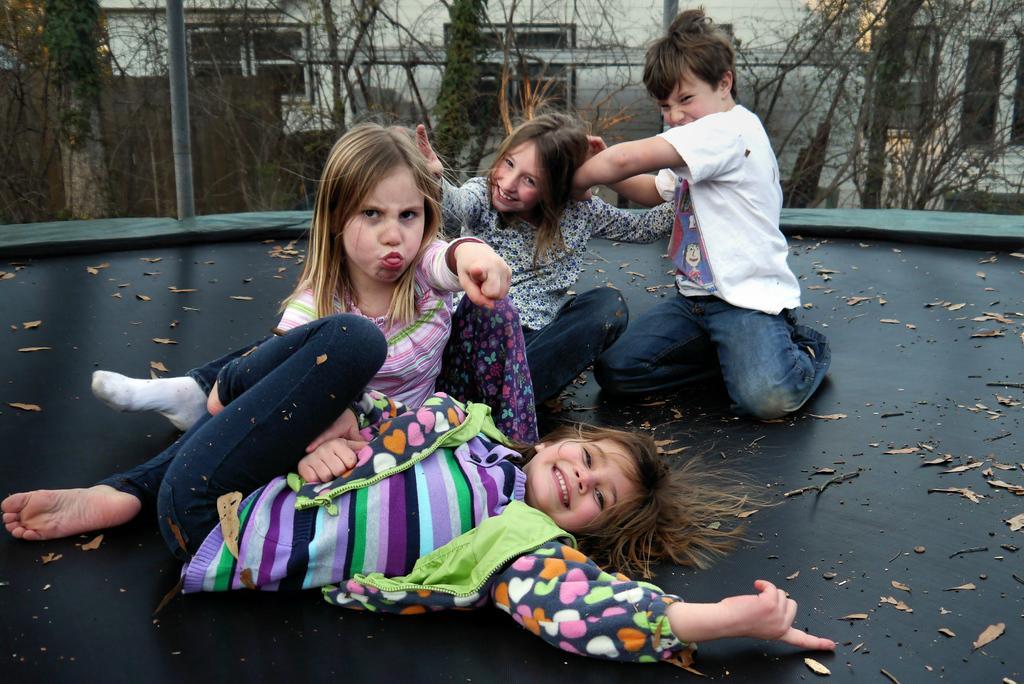Could you give a brief overview of what you see in this image? This image consists of trees at the top. There are 4 persons in the middle. Three are girls, one is a boy. They are playing. 